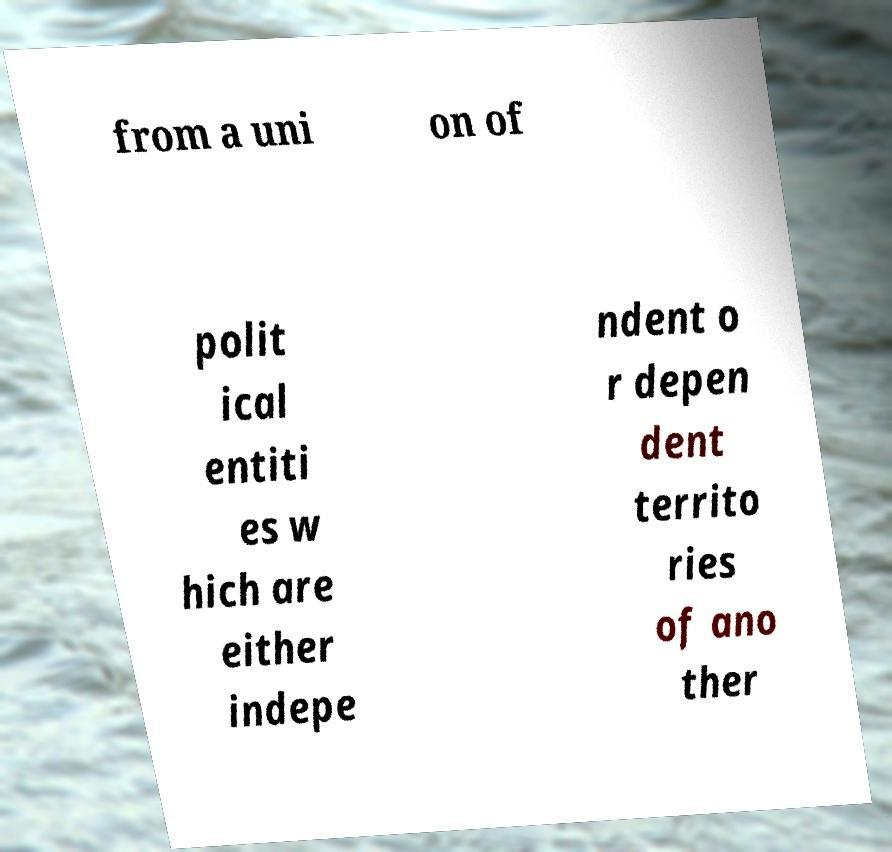Please read and relay the text visible in this image. What does it say? from a uni on of polit ical entiti es w hich are either indepe ndent o r depen dent territo ries of ano ther 